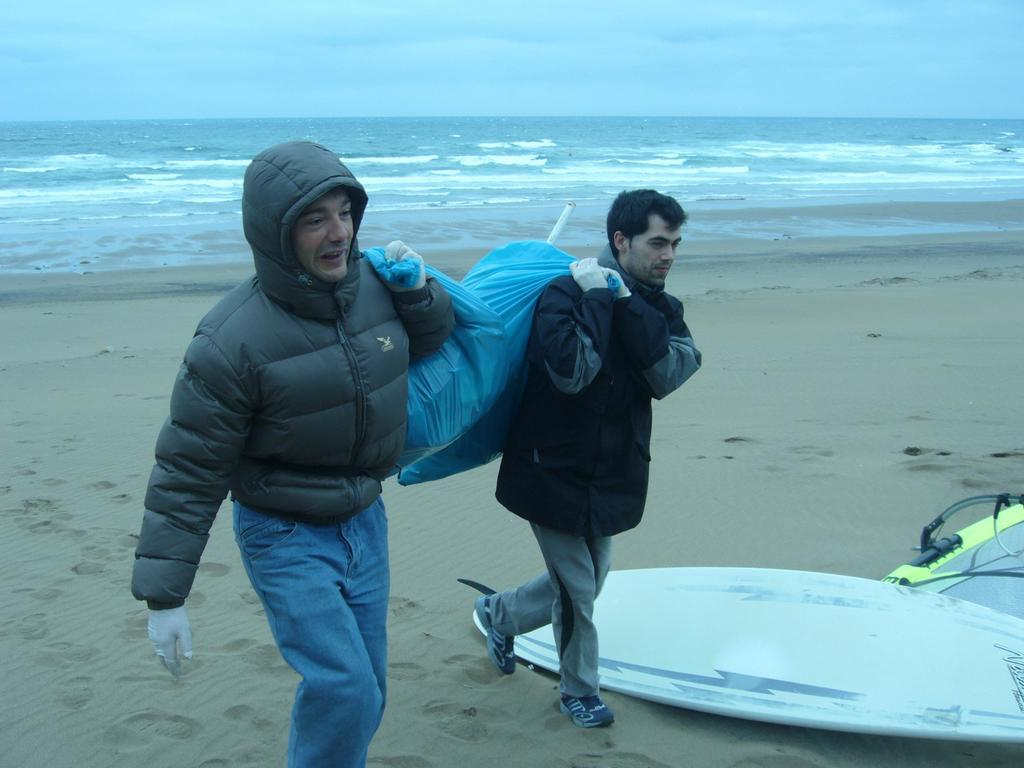How many people are in the image? There are two persons standing in the image. What are the persons holding? The persons are holding bags. What can be seen on the seashore? There are surfboards on the seashore. What is visible in the image besides the people and surfboards? There is water visible in the image, and the sky is visible in the background. What type of floor can be seen in the image? There is no floor visible in the image, as it appears to be taken outdoors near the seashore. 